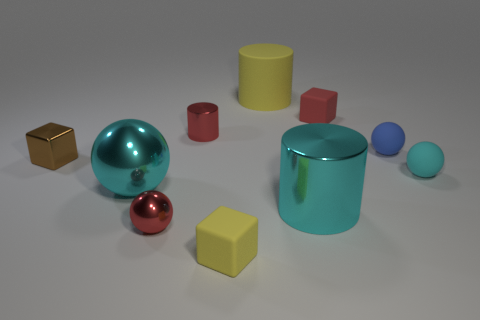What number of objects are behind the brown shiny object and right of the tiny yellow object?
Provide a succinct answer. 3. There is a cylinder that is in front of the tiny block that is to the left of the small yellow object; what is its size?
Give a very brief answer. Large. Is there any other thing that is the same material as the cyan cylinder?
Provide a succinct answer. Yes. Are there more big red things than shiny cylinders?
Make the answer very short. No. Do the matte thing that is behind the red matte object and the tiny matte thing behind the blue sphere have the same color?
Provide a succinct answer. No. Is there a blue rubber ball that is to the left of the large cyan shiny ball that is in front of the small blue matte thing?
Ensure brevity in your answer.  No. Are there fewer tiny blocks that are in front of the yellow matte block than yellow matte blocks right of the tiny red block?
Make the answer very short. No. Do the red object that is in front of the red shiny cylinder and the block behind the small red cylinder have the same material?
Ensure brevity in your answer.  No. How many small objects are either red metal objects or purple shiny things?
Offer a terse response. 2. What shape is the cyan object that is the same material as the tiny blue sphere?
Keep it short and to the point. Sphere. 